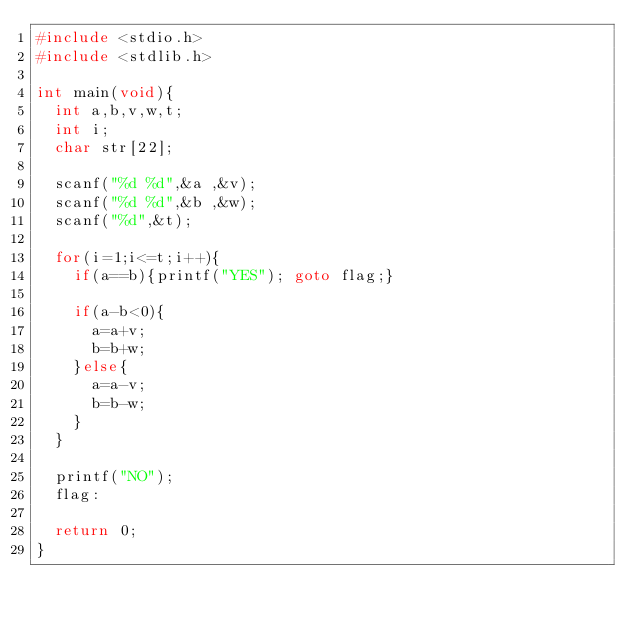<code> <loc_0><loc_0><loc_500><loc_500><_C_>#include <stdio.h>
#include <stdlib.h>

int main(void){
  int a,b,v,w,t;
  int i;
  char str[22];
  
  scanf("%d %d",&a ,&v);
  scanf("%d %d",&b ,&w);
  scanf("%d",&t);
  
  for(i=1;i<=t;i++){
    if(a==b){printf("YES"); goto flag;}
    
    if(a-b<0){
      a=a+v;
      b=b+w;
    }else{
      a=a-v;
      b=b-w;
    }
  }
  
  printf("NO");
  flag:
  
  return 0;
}</code> 